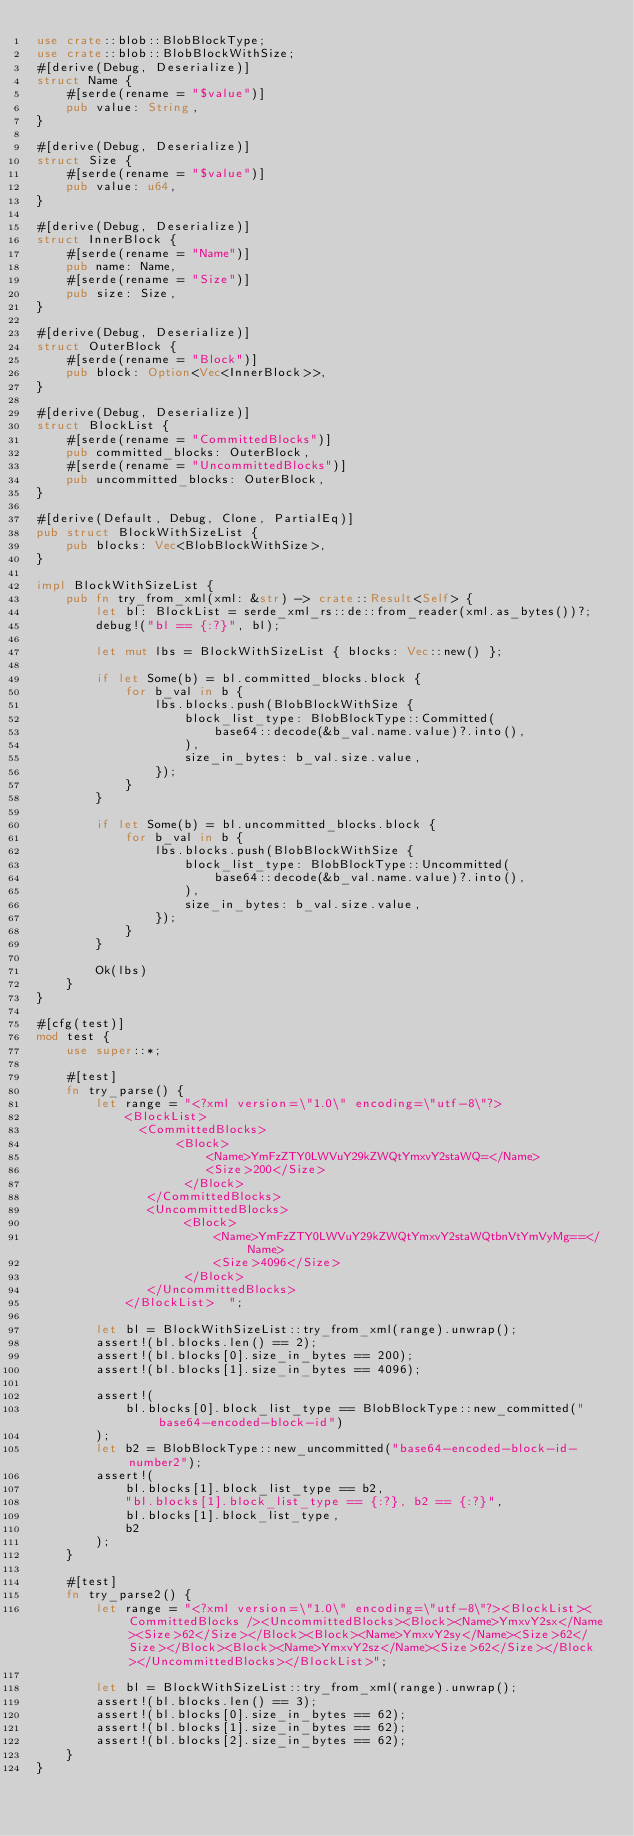Convert code to text. <code><loc_0><loc_0><loc_500><loc_500><_Rust_>use crate::blob::BlobBlockType;
use crate::blob::BlobBlockWithSize;
#[derive(Debug, Deserialize)]
struct Name {
    #[serde(rename = "$value")]
    pub value: String,
}

#[derive(Debug, Deserialize)]
struct Size {
    #[serde(rename = "$value")]
    pub value: u64,
}

#[derive(Debug, Deserialize)]
struct InnerBlock {
    #[serde(rename = "Name")]
    pub name: Name,
    #[serde(rename = "Size")]
    pub size: Size,
}

#[derive(Debug, Deserialize)]
struct OuterBlock {
    #[serde(rename = "Block")]
    pub block: Option<Vec<InnerBlock>>,
}

#[derive(Debug, Deserialize)]
struct BlockList {
    #[serde(rename = "CommittedBlocks")]
    pub committed_blocks: OuterBlock,
    #[serde(rename = "UncommittedBlocks")]
    pub uncommitted_blocks: OuterBlock,
}

#[derive(Default, Debug, Clone, PartialEq)]
pub struct BlockWithSizeList {
    pub blocks: Vec<BlobBlockWithSize>,
}

impl BlockWithSizeList {
    pub fn try_from_xml(xml: &str) -> crate::Result<Self> {
        let bl: BlockList = serde_xml_rs::de::from_reader(xml.as_bytes())?;
        debug!("bl == {:?}", bl);

        let mut lbs = BlockWithSizeList { blocks: Vec::new() };

        if let Some(b) = bl.committed_blocks.block {
            for b_val in b {
                lbs.blocks.push(BlobBlockWithSize {
                    block_list_type: BlobBlockType::Committed(
                        base64::decode(&b_val.name.value)?.into(),
                    ),
                    size_in_bytes: b_val.size.value,
                });
            }
        }

        if let Some(b) = bl.uncommitted_blocks.block {
            for b_val in b {
                lbs.blocks.push(BlobBlockWithSize {
                    block_list_type: BlobBlockType::Uncommitted(
                        base64::decode(&b_val.name.value)?.into(),
                    ),
                    size_in_bytes: b_val.size.value,
                });
            }
        }

        Ok(lbs)
    }
}

#[cfg(test)]
mod test {
    use super::*;

    #[test]
    fn try_parse() {
        let range = "<?xml version=\"1.0\" encoding=\"utf-8\"?>
            <BlockList>
              <CommittedBlocks>
                   <Block>
                       <Name>YmFzZTY0LWVuY29kZWQtYmxvY2staWQ=</Name>
                       <Size>200</Size>
                    </Block>
               </CommittedBlocks>
               <UncommittedBlocks>
                    <Block>
                        <Name>YmFzZTY0LWVuY29kZWQtYmxvY2staWQtbnVtYmVyMg==</Name>
                        <Size>4096</Size>
                    </Block>
               </UncommittedBlocks>
            </BlockList>  ";

        let bl = BlockWithSizeList::try_from_xml(range).unwrap();
        assert!(bl.blocks.len() == 2);
        assert!(bl.blocks[0].size_in_bytes == 200);
        assert!(bl.blocks[1].size_in_bytes == 4096);

        assert!(
            bl.blocks[0].block_list_type == BlobBlockType::new_committed("base64-encoded-block-id")
        );
        let b2 = BlobBlockType::new_uncommitted("base64-encoded-block-id-number2");
        assert!(
            bl.blocks[1].block_list_type == b2,
            "bl.blocks[1].block_list_type == {:?}, b2 == {:?}",
            bl.blocks[1].block_list_type,
            b2
        );
    }

    #[test]
    fn try_parse2() {
        let range = "<?xml version=\"1.0\" encoding=\"utf-8\"?><BlockList><CommittedBlocks /><UncommittedBlocks><Block><Name>YmxvY2sx</Name><Size>62</Size></Block><Block><Name>YmxvY2sy</Name><Size>62</Size></Block><Block><Name>YmxvY2sz</Name><Size>62</Size></Block></UncommittedBlocks></BlockList>";

        let bl = BlockWithSizeList::try_from_xml(range).unwrap();
        assert!(bl.blocks.len() == 3);
        assert!(bl.blocks[0].size_in_bytes == 62);
        assert!(bl.blocks[1].size_in_bytes == 62);
        assert!(bl.blocks[2].size_in_bytes == 62);
    }
}
</code> 